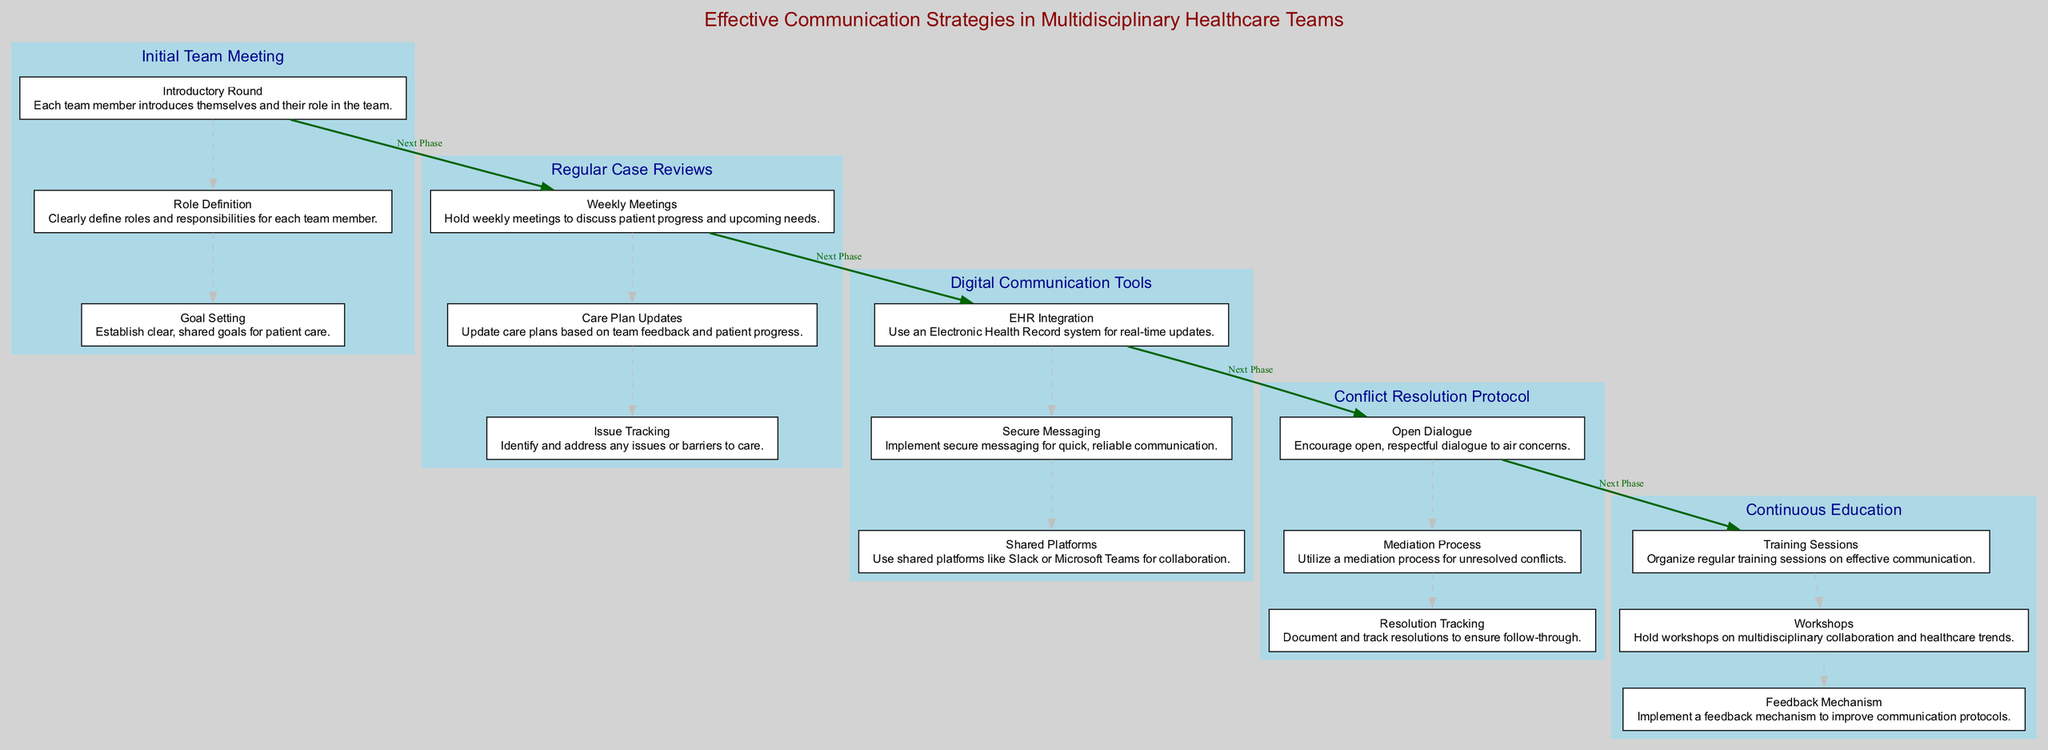What is the first element in the diagram? The diagram shows the elements listed in order, starting with "Initial Team Meeting" as the first element.
Answer: Initial Team Meeting How many components are in the "Regular Case Reviews" element? In the "Regular Case Reviews" element, there are three components listed.
Answer: 3 What is the action required in the "Open Dialogue" step? The "Open Dialogue" step requires encouraging open, respectful dialogue to air concerns, as described in the component section of the "Conflict Resolution Protocol."
Answer: Encourage open, respectful dialogue What connects "Continuous Education" and "Initial Team Meeting"? The connection between "Continuous Education" and "Initial Team Meeting" is labeled as "Next Phase," indicating the flow of the clinical pathway from one element to the next.
Answer: Next Phase Which communication tool is recommended for real-time updates? The recommended tool for real-time updates is an Electronic Health Record system, which falls under the "Digital Communication Tools" element.
Answer: Electronic Health Record system What is the last step in the "Digital Communication Tools" component? The last step under the "Digital Communication Tools" component is using shared platforms like Slack or Microsoft Teams for collaboration.
Answer: Use shared platforms like Slack or Microsoft Teams How many steps are included in the "Continuous Education" element? The "Continuous Education" element includes three steps focused on training sessions, workshops, and a feedback mechanism.
Answer: 3 What is the purpose of "Conflict Resolution Protocol"? The purpose of "Conflict Resolution Protocol" is to establish clear procedures to handle conflicts and disagreements among team members.
Answer: Establish clear procedures What is the relationship between "Initial Team Meeting" and "Regular Case Reviews"? The relationship is a sequential one, where "Initial Team Meeting" leads into "Regular Case Reviews," indicating a flow in the clinical pathway.
Answer: Sequential flow 